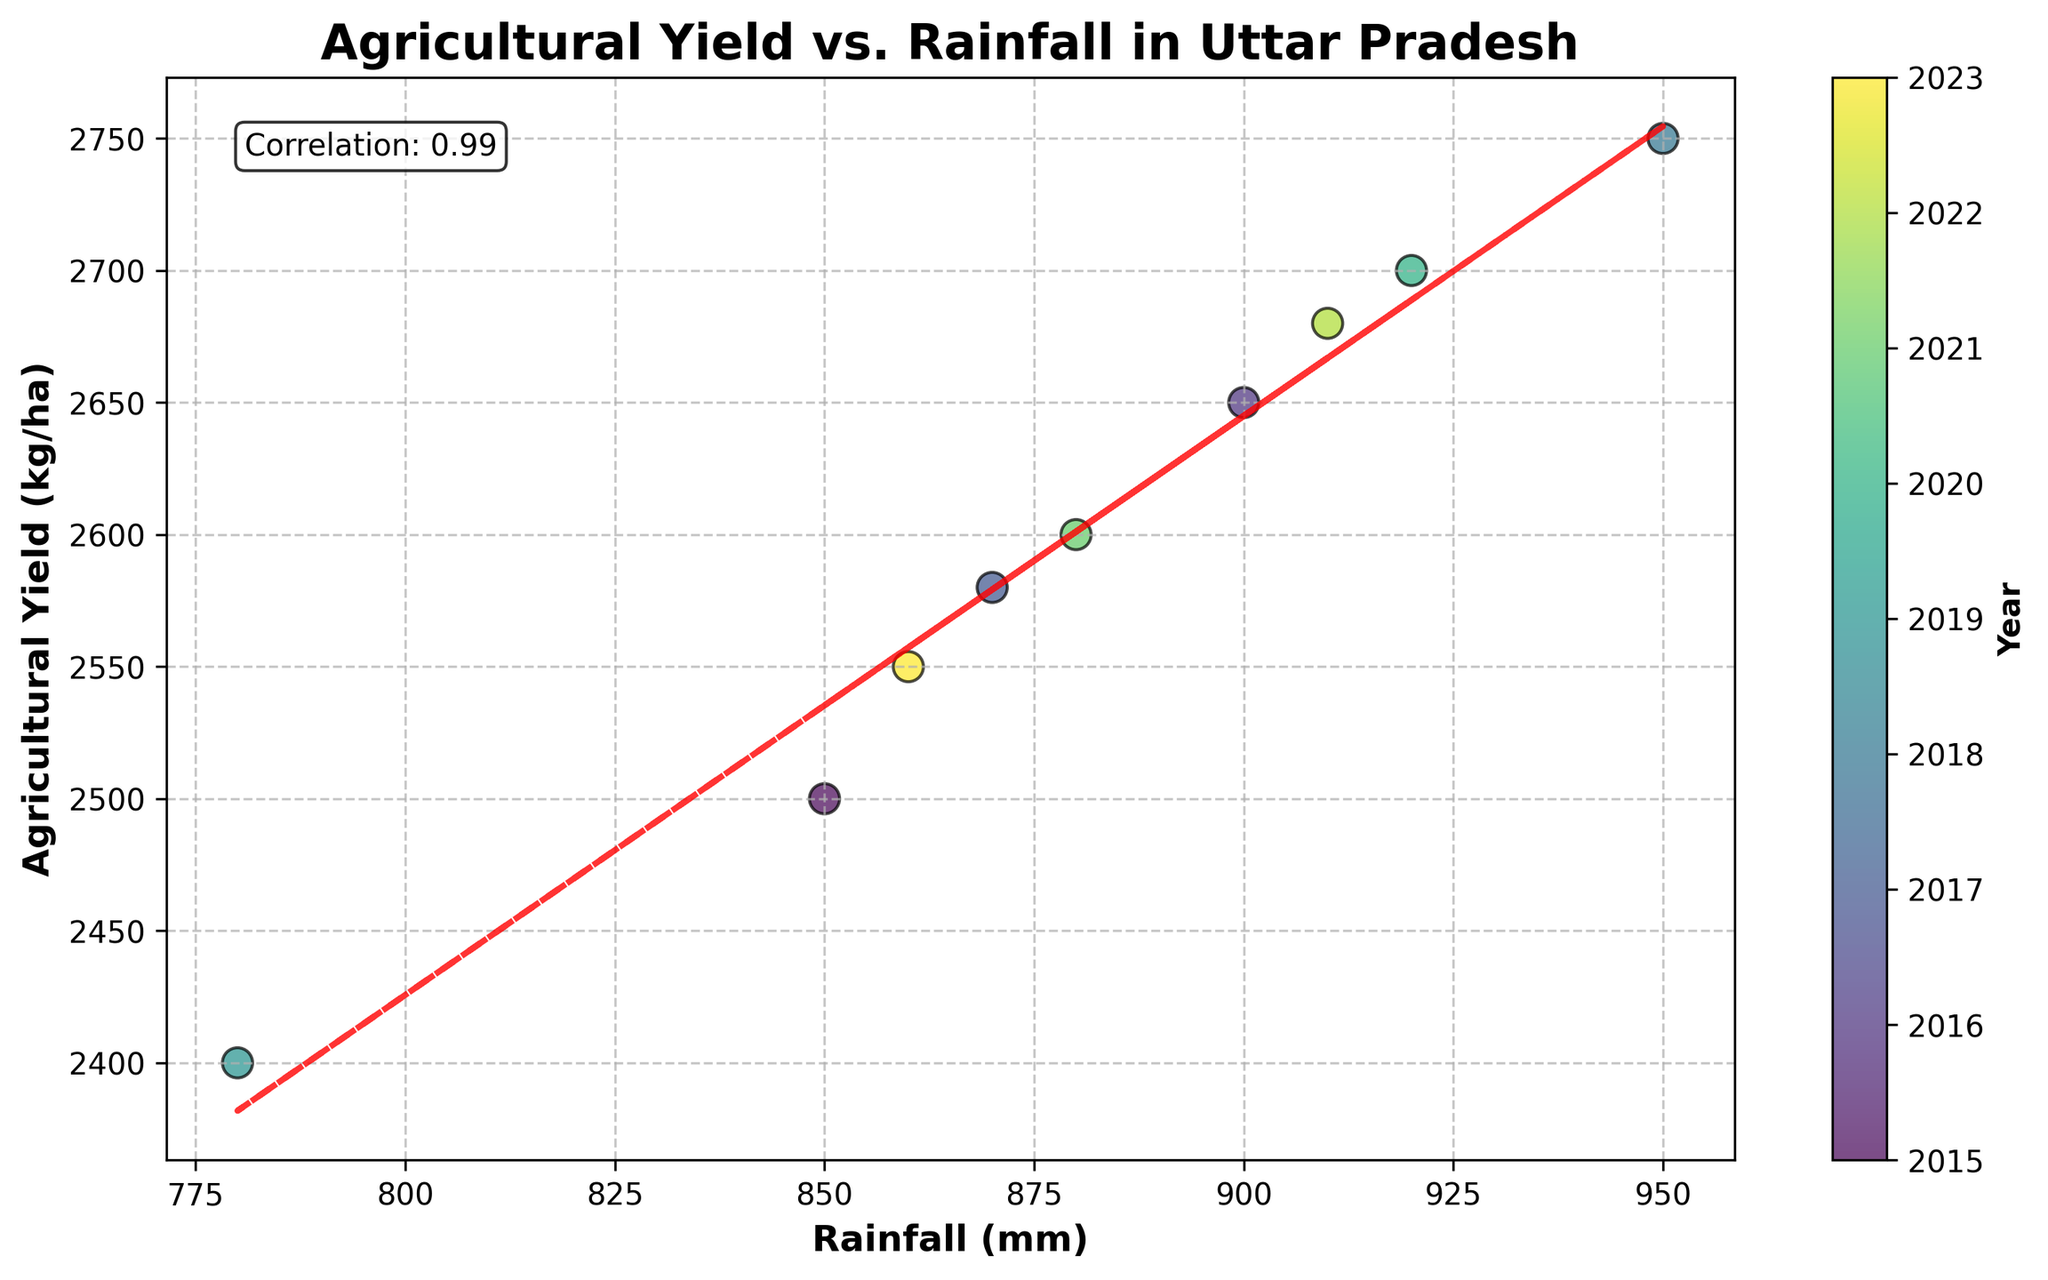What is the title of the plot? The title of the plot is displayed in a prominent position, usually at the top of the figure. It provides an overview of what the plot is depicting.
Answer: Agricultural Yield vs. Rainfall in Uttar Pradesh How many data points are shown in the figure? The number of distinct markers (dots) on the scatter plot represents the number of data points included in the figure.
Answer: 9 What does the x-axis represent? The x-axis label provides information about what data is shown along the horizontal axis.
Answer: Rainfall (mm) What does the y-axis represent? The y-axis label provides information about what data is shown along the vertical axis.
Answer: Agricultural Yield (kg/ha) How does the agricultural yield change as rainfall increases? Observing the trend line, you can see the general direction in which the agricultural yield changes with respect to rainfall. A line with a positive slope indicates an increasing trend.
Answer: It generally increases Which year had the lowest rainfall, and what was the corresponding agricultural yield? By identifying the data point corresponding to the lowest value on the x-axis and checking its y-value as well as referring to the color map for the year. The scatter plot has a color gradient that helps identify the year based on color.
Answer: 2019, 2400 kg/ha How is the correlation between rainfall and agricultural yield described, and what is the value? The text box within the plot mentions the correlation coefficient, which quantifies the strength and direction of the linear relationship.
Answer: Correlation: 0.87 What is the agricultural yield for the year 2022? By locating the data point for the year 2022 using the color gradient and checking its corresponding y-axis value.
Answer: 2680 kg/ha Which year had the highest agricultural yield, and what was the rainfall in that year? Identify the highest data point on the y-axis and check its x-value, using the color map to find the corresponding year.
Answer: 2018, 950 mm Is there a year where agricultural yield decreased despite an increase in rainfall? Comparing the data points, look for a situation where y decreases even though x increases by examining adjacent years on the color gradient.
Answer: Yes, from 2020 to 2021 